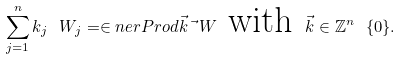Convert formula to latex. <formula><loc_0><loc_0><loc_500><loc_500>\sum _ { j = 1 } ^ { n } k _ { j } \ W _ { j } = \in n e r P r o d { \vec { k } } { \vec { \ } W } \text { with } \vec { k } \in { \mathbb { Z } } ^ { n } \ \{ 0 \} .</formula> 